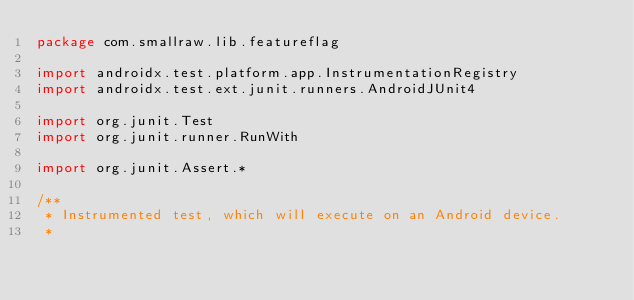Convert code to text. <code><loc_0><loc_0><loc_500><loc_500><_Kotlin_>package com.smallraw.lib.featureflag

import androidx.test.platform.app.InstrumentationRegistry
import androidx.test.ext.junit.runners.AndroidJUnit4

import org.junit.Test
import org.junit.runner.RunWith

import org.junit.Assert.*

/**
 * Instrumented test, which will execute on an Android device.
 *</code> 